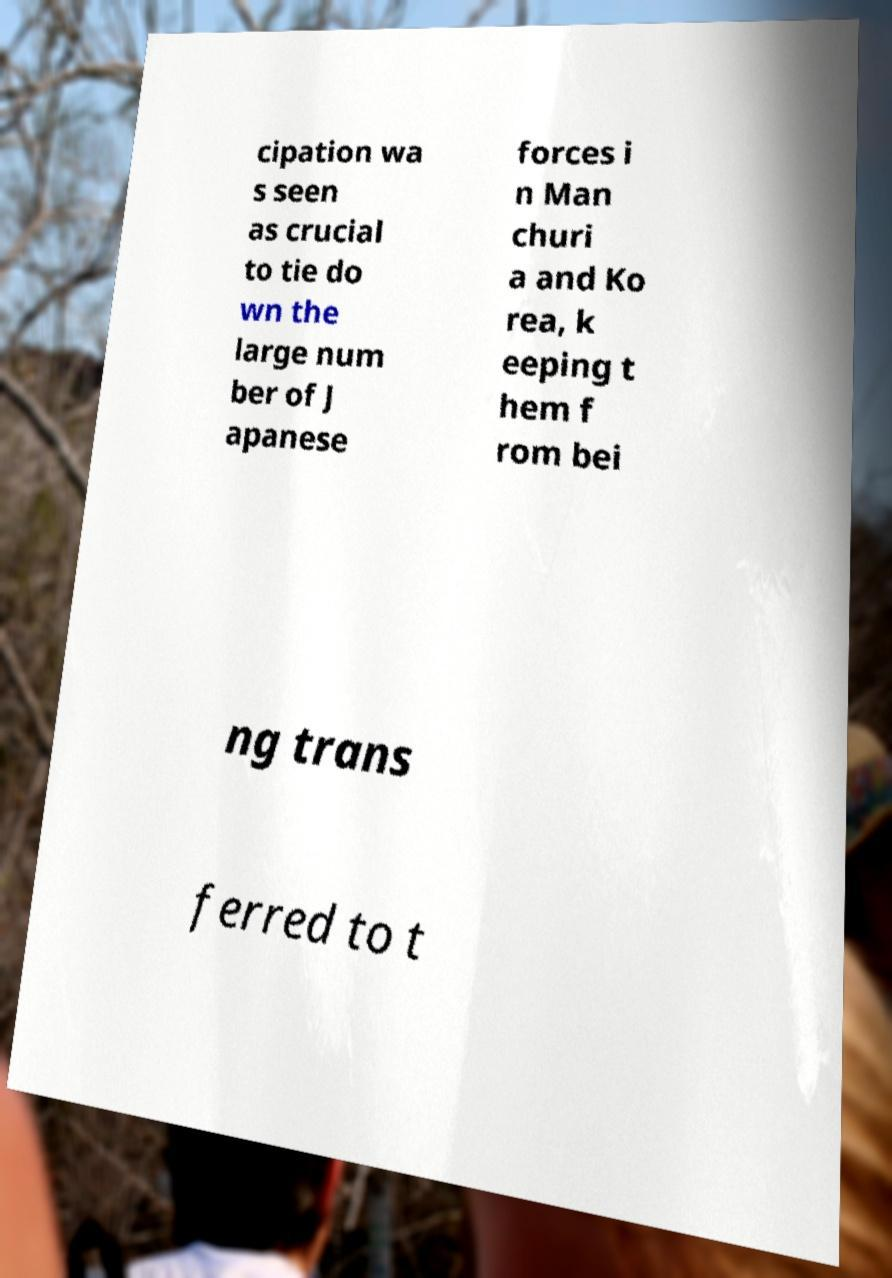Please read and relay the text visible in this image. What does it say? cipation wa s seen as crucial to tie do wn the large num ber of J apanese forces i n Man churi a and Ko rea, k eeping t hem f rom bei ng trans ferred to t 